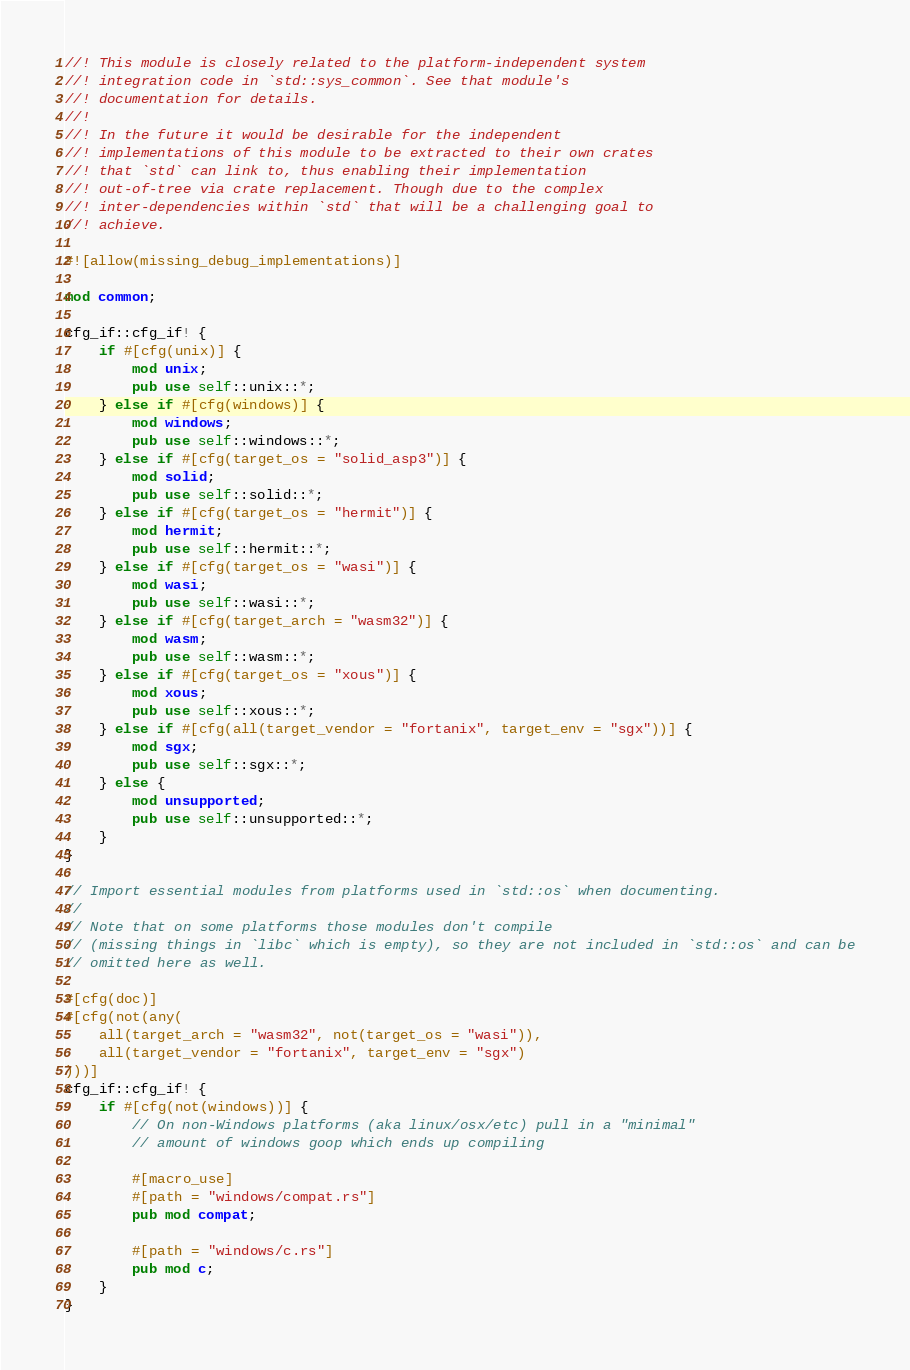Convert code to text. <code><loc_0><loc_0><loc_500><loc_500><_Rust_>//! This module is closely related to the platform-independent system
//! integration code in `std::sys_common`. See that module's
//! documentation for details.
//!
//! In the future it would be desirable for the independent
//! implementations of this module to be extracted to their own crates
//! that `std` can link to, thus enabling their implementation
//! out-of-tree via crate replacement. Though due to the complex
//! inter-dependencies within `std` that will be a challenging goal to
//! achieve.

#![allow(missing_debug_implementations)]

mod common;

cfg_if::cfg_if! {
    if #[cfg(unix)] {
        mod unix;
        pub use self::unix::*;
    } else if #[cfg(windows)] {
        mod windows;
        pub use self::windows::*;
    } else if #[cfg(target_os = "solid_asp3")] {
        mod solid;
        pub use self::solid::*;
    } else if #[cfg(target_os = "hermit")] {
        mod hermit;
        pub use self::hermit::*;
    } else if #[cfg(target_os = "wasi")] {
        mod wasi;
        pub use self::wasi::*;
    } else if #[cfg(target_arch = "wasm32")] {
        mod wasm;
        pub use self::wasm::*;
    } else if #[cfg(target_os = "xous")] {
        mod xous;
        pub use self::xous::*;
    } else if #[cfg(all(target_vendor = "fortanix", target_env = "sgx"))] {
        mod sgx;
        pub use self::sgx::*;
    } else {
        mod unsupported;
        pub use self::unsupported::*;
    }
}

// Import essential modules from platforms used in `std::os` when documenting.
//
// Note that on some platforms those modules don't compile
// (missing things in `libc` which is empty), so they are not included in `std::os` and can be
// omitted here as well.

#[cfg(doc)]
#[cfg(not(any(
    all(target_arch = "wasm32", not(target_os = "wasi")),
    all(target_vendor = "fortanix", target_env = "sgx")
)))]
cfg_if::cfg_if! {
    if #[cfg(not(windows))] {
        // On non-Windows platforms (aka linux/osx/etc) pull in a "minimal"
        // amount of windows goop which ends up compiling

        #[macro_use]
        #[path = "windows/compat.rs"]
        pub mod compat;

        #[path = "windows/c.rs"]
        pub mod c;
    }
}
</code> 